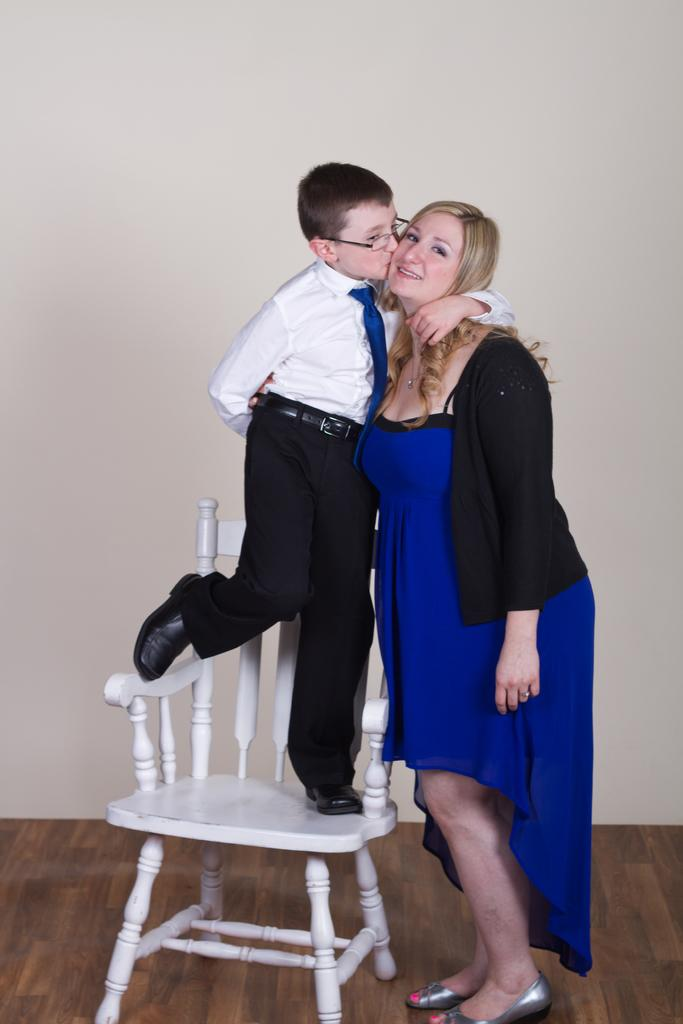Who are the people in the image? There is a boy and a woman in the image. What is the boy doing in the image? The boy is standing on a chair. Can you describe the boy's appearance? The boy is wearing glasses (specs). How does the woman appear in the image? There is a smile on the woman's face. What type of fang can be seen in the boy's mouth in the image? There is no fang visible in the boy's mouth in the image. What kind of sand is present on the chair the boy is standing on? There is no sand present on the chair the boy is standing on in the image. 